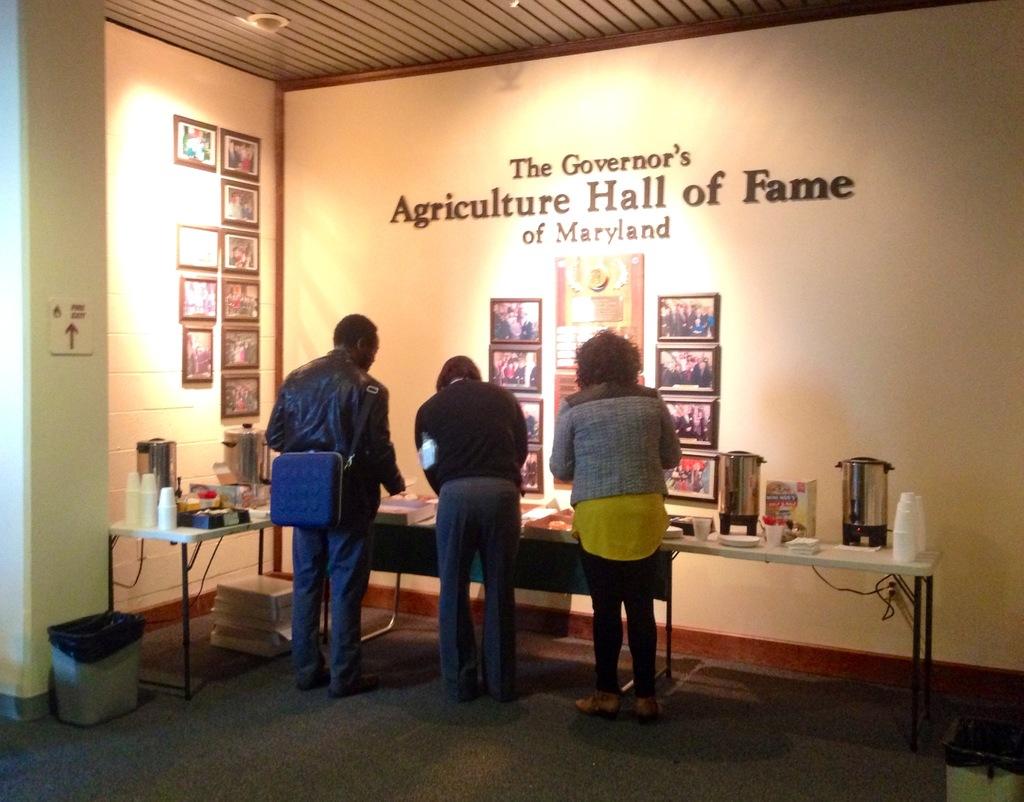What state is this building in?
Offer a very short reply. Maryland. 